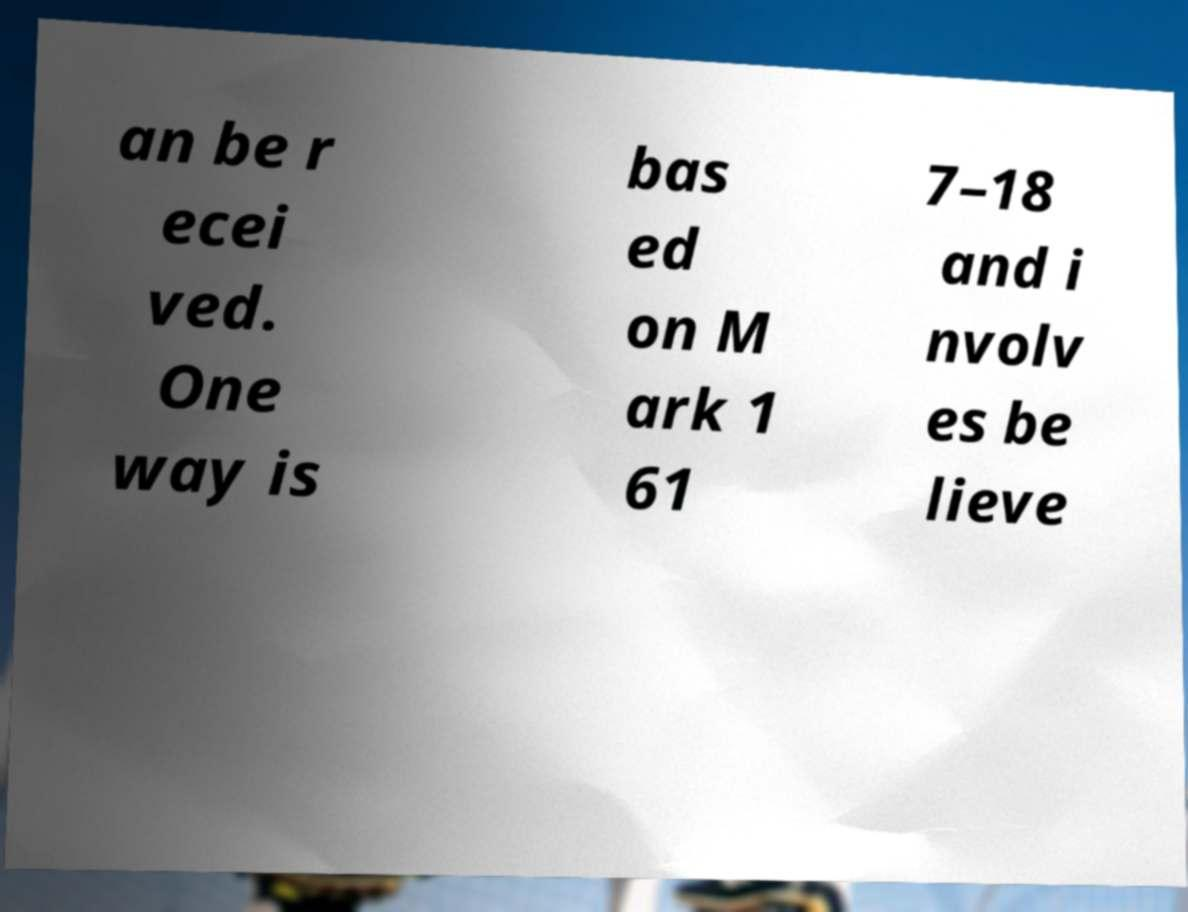I need the written content from this picture converted into text. Can you do that? an be r ecei ved. One way is bas ed on M ark 1 61 7–18 and i nvolv es be lieve 